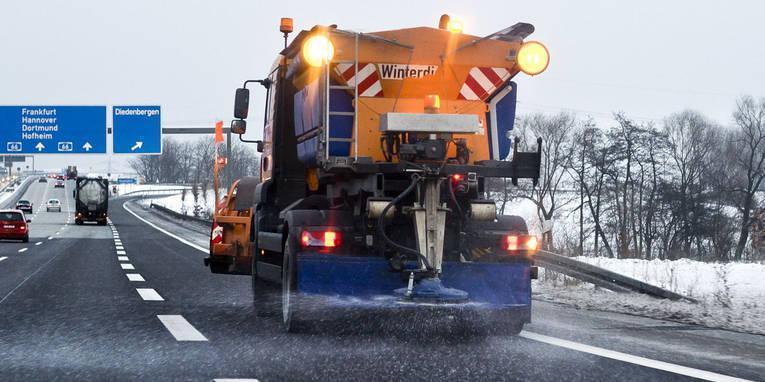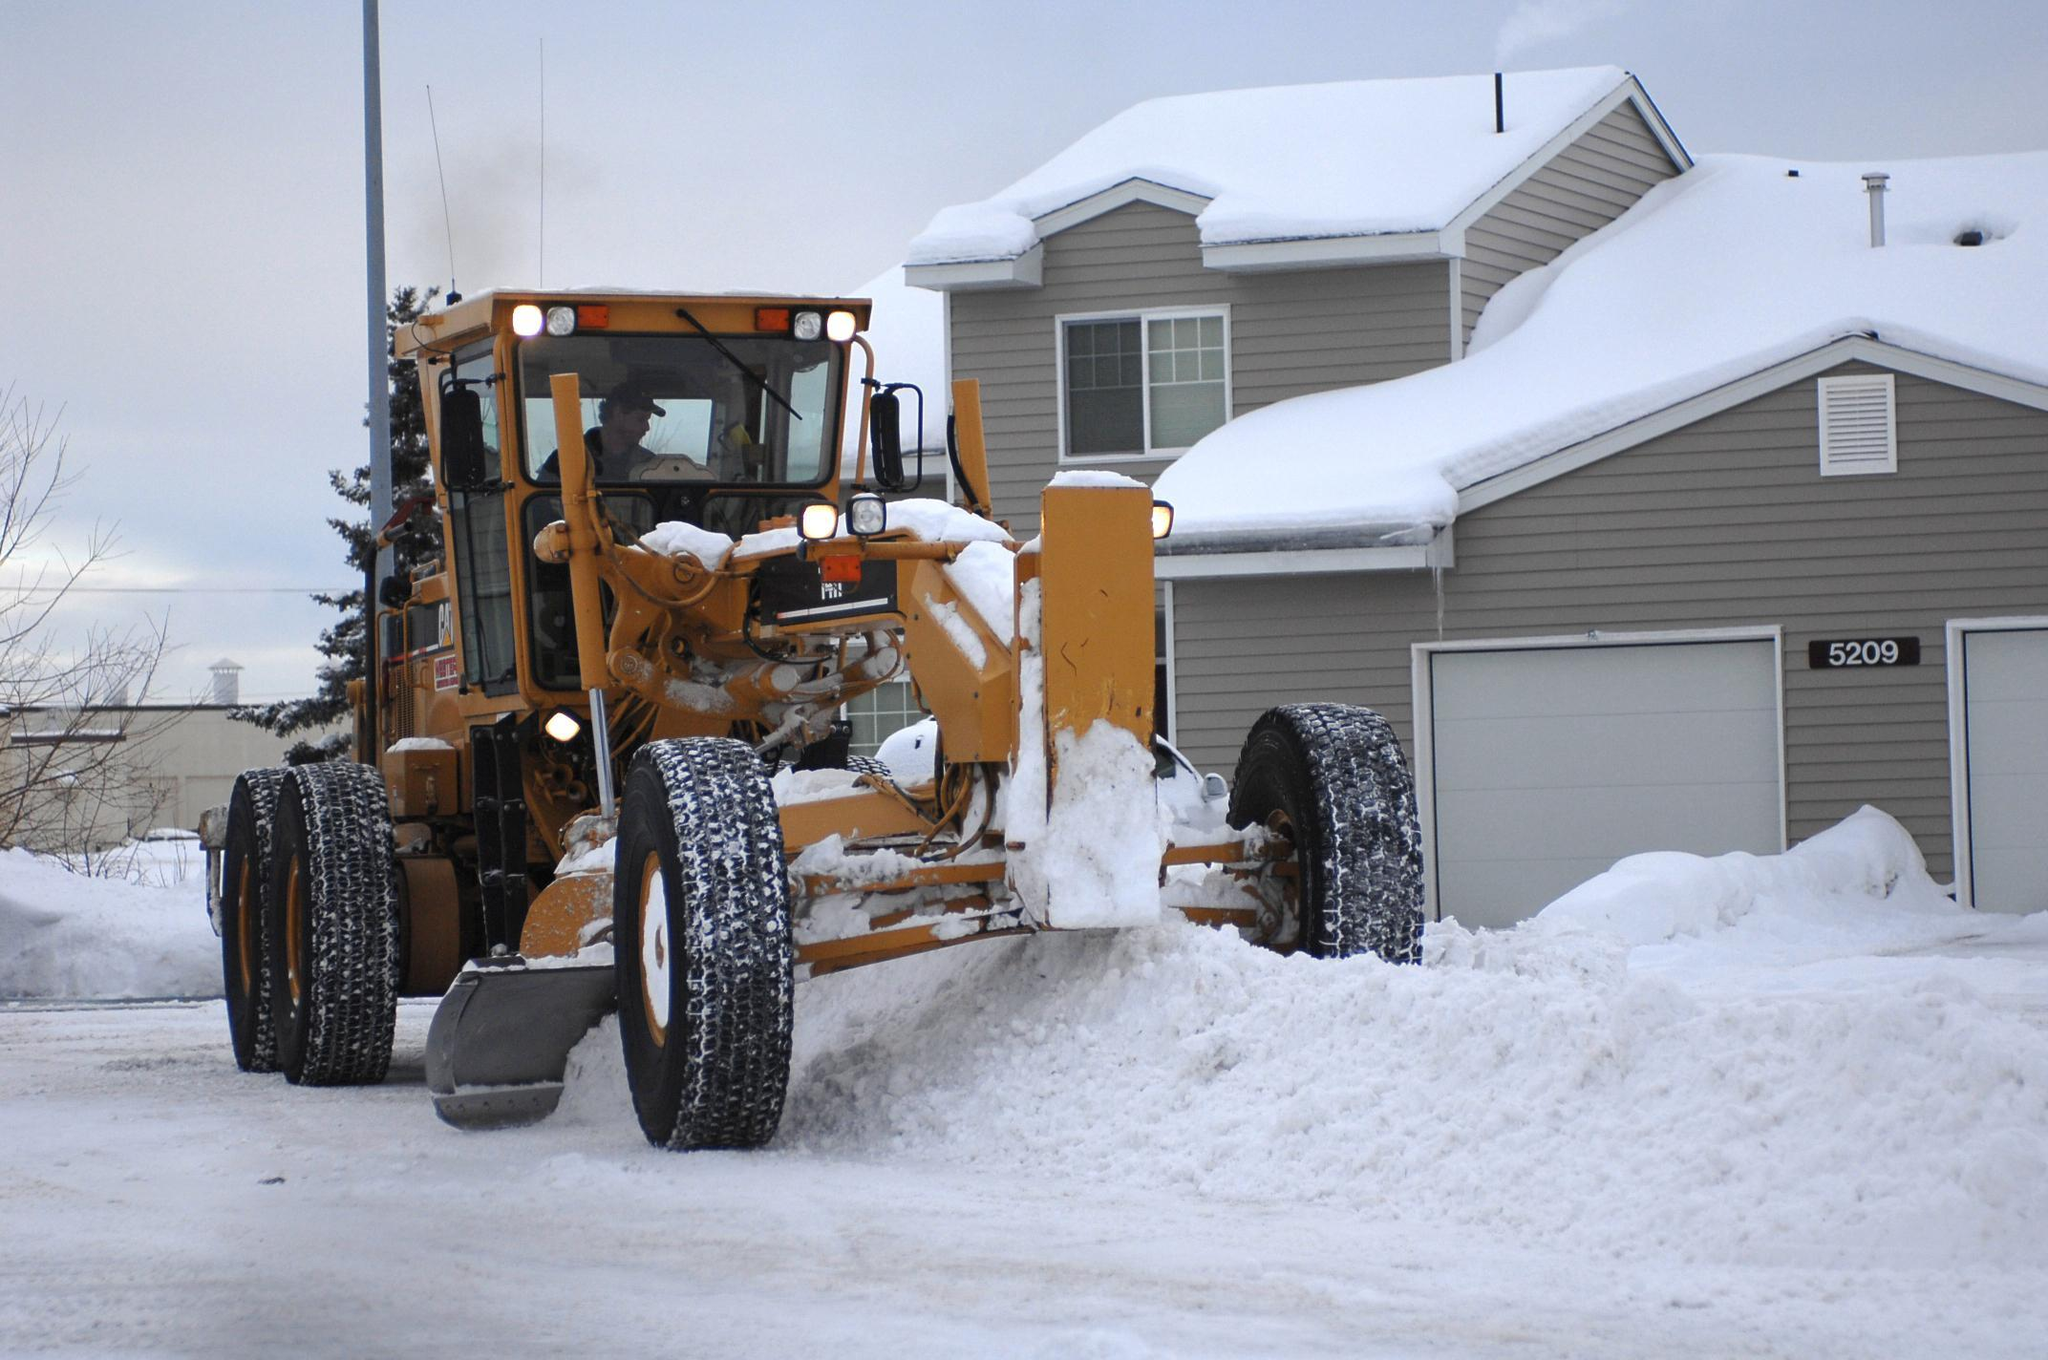The first image is the image on the left, the second image is the image on the right. Examine the images to the left and right. Is the description "The vehicle in the right image is driving in front of a house" accurate? Answer yes or no. Yes. 